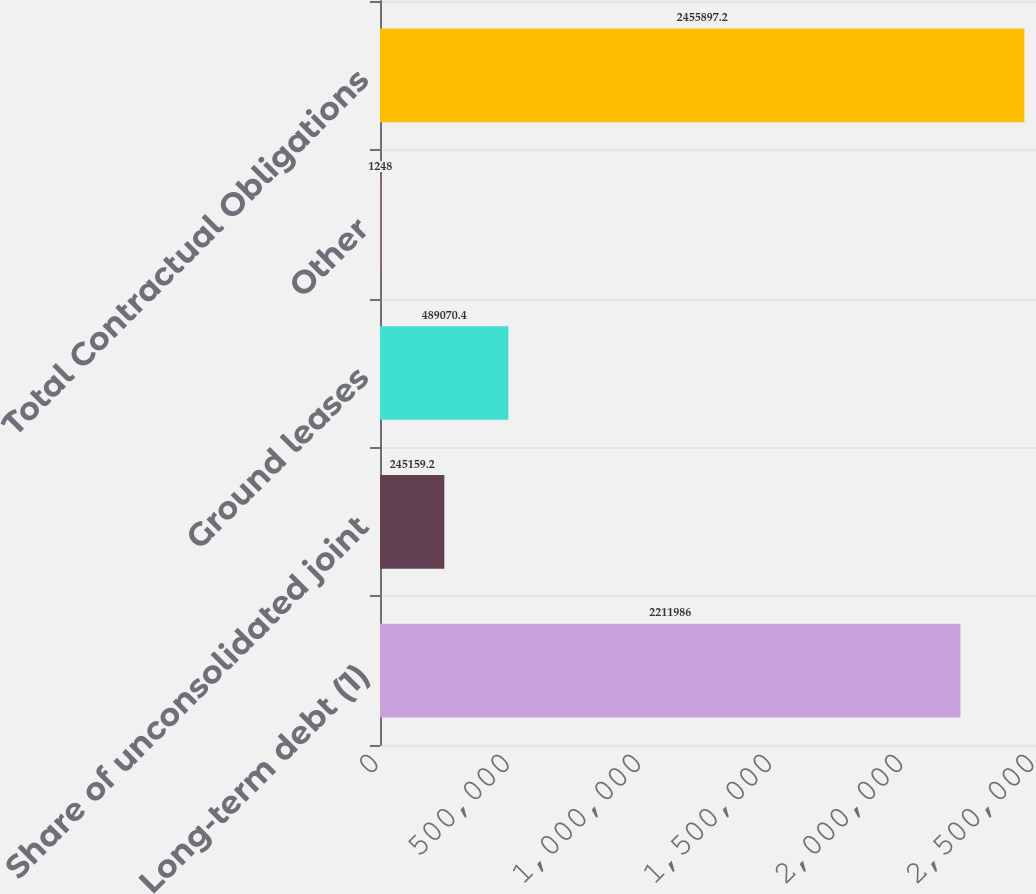<chart> <loc_0><loc_0><loc_500><loc_500><bar_chart><fcel>Long-term debt (1)<fcel>Share of unconsolidated joint<fcel>Ground leases<fcel>Other<fcel>Total Contractual Obligations<nl><fcel>2.21199e+06<fcel>245159<fcel>489070<fcel>1248<fcel>2.4559e+06<nl></chart> 